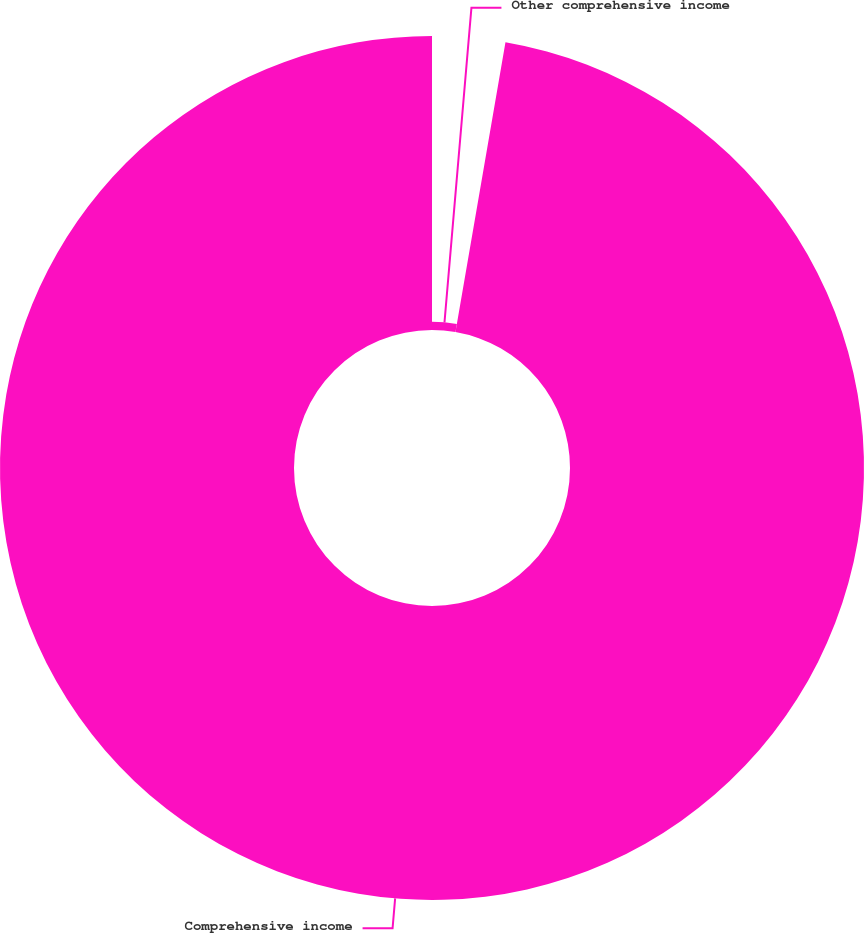<chart> <loc_0><loc_0><loc_500><loc_500><pie_chart><fcel>Other comprehensive income<fcel>Comprehensive income<nl><fcel>2.72%<fcel>97.28%<nl></chart> 